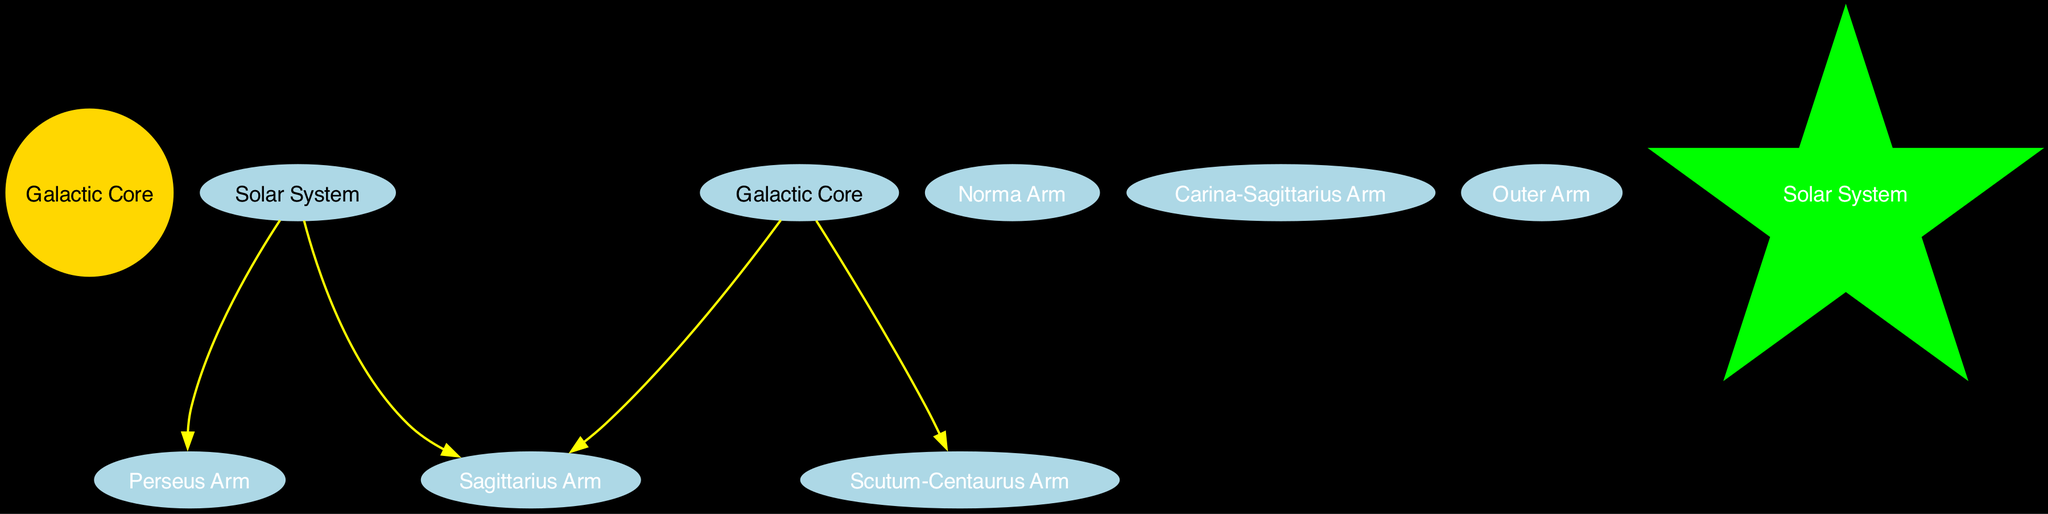What is located at the center of the Milky Way? The diagram identifies the central region of the Milky Way as the "Galactic Core," which is labeled prominently in a gold circle.
Answer: Galactic Core How many spiral arms are shown in the diagram? The diagram depicts six spiral arms, as indicated by the labels around the central Galactic Core, which includes Perseus, Sagittarius, Norma, Scutum-Centaurus, Carina-Sagittarius, and Outer Arm.
Answer: Six Which arm is described as "rich in star-forming regions"? The Perseus Arm is specifically labeled in the diagram as "rich in star-forming regions," providing clear descriptive information about its characteristics.
Answer: Perseus Arm What is the Earth's position referred to as in the diagram? The diagram uses the label "Solar System" for Earth's position, visually represented in a unique star shape colored green.
Answer: Solar System Which arm contains the famous Lagoon Nebula? The diagram clearly shows that the Sagittarius Arm has a description stating it contains the famous Lagoon Nebula, emphasizing its significance in the structure.
Answer: Sagittarius Arm What is the connection between the Galactic Core and the Scutum-Centaurus Arm? The diagram indicates a direct connection labeled "Core to Scutum-Centaurus Arm," showing the relationship between these two elements in the Milky Way's structure.
Answer: Core to Scutum-Centaurus Arm Which spiral arm is located between the Norma and Scutum-Centaurus arms? The Carina-Sagittarius Arm is identified in the diagram as the small segment situated between the Norma and Scutum-Centaurus arms of the Milky Way.
Answer: Carina-Sagittarius Arm What color represents the Galactic Core in the diagram? The Galactic Core is represented in gold, highlighting its central and prominent position in the visualization of the Milky Way's structure.
Answer: Gold How many connections involve the Solar System? The diagram depicts two connections involving the Solar System: from the Solar System to the Perseus Arm and from the Solar System to the Sagittarius Arm.
Answer: Two 